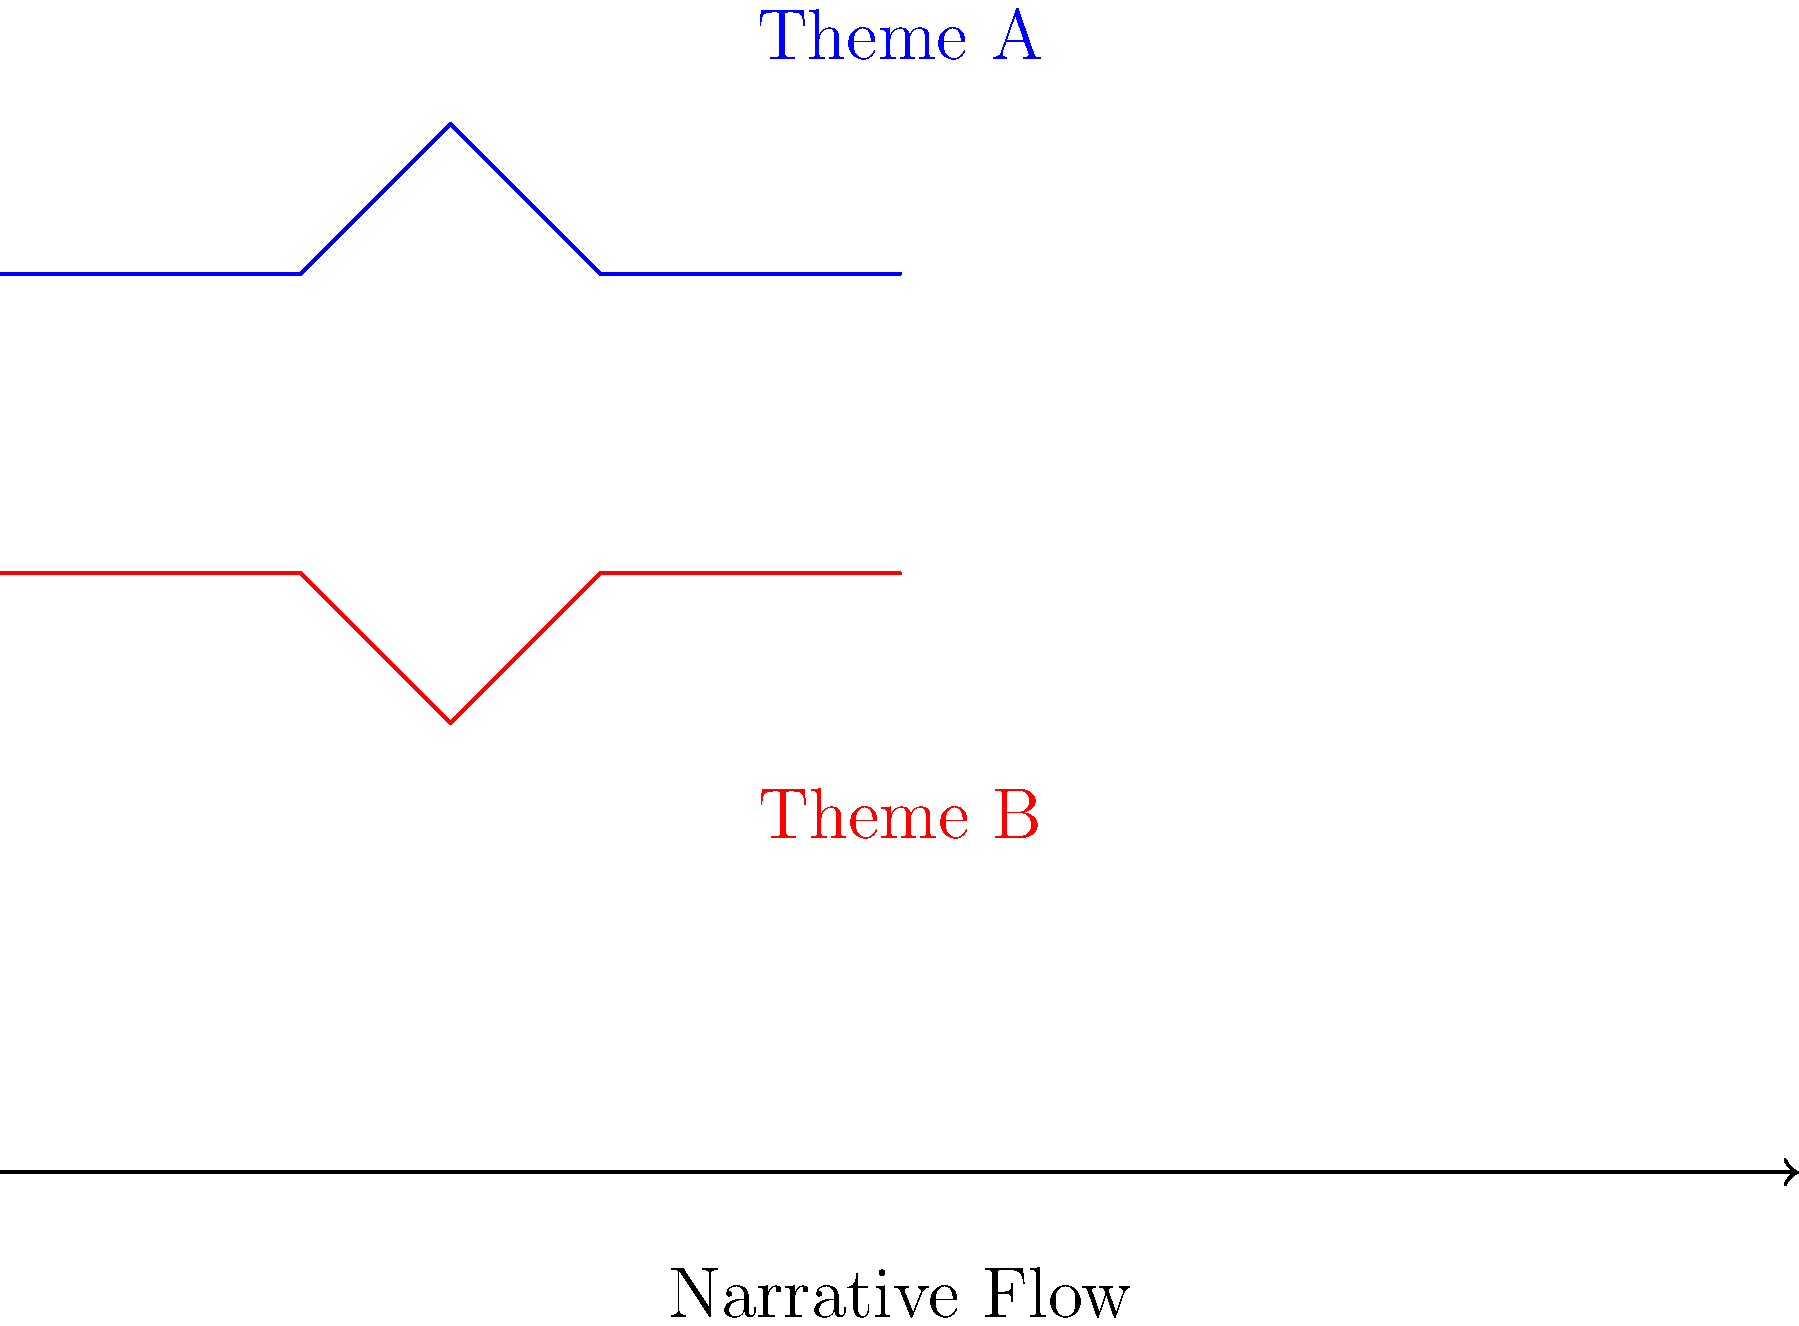In the context of narrative structure, how does the glide reflection illustrated in the frieze pattern above relate to the recurring themes across multiple works? Explain the significance of this transformation in enhancing narrative flow and clarity. 1. Observe the frieze pattern: The blue path (Theme A) is reflected and translated to create the red path (Theme B).

2. Glide reflection: This transformation combines reflection and translation. In literature, it represents how themes are mirrored and shifted across a narrative or multiple works.

3. Recurring themes: The similarity between Theme A and Theme B shows how core ideas persist but are presented from different perspectives or at different points in the story.

4. Narrative flow: The horizontal arrow represents the progression of the narrative. The glide reflection shows how themes evolve along this flow.

5. Clarity enhancement: By presenting themes in a transformed manner, authors can:
   a) Reinforce key ideas without exact repetition
   b) Show theme development or different facets of a concept
   c) Create symmetry and balance in the overall narrative structure

6. Multiple works: This pattern can extend across an author's body of work, showing thematic consistency and evolution over time.

7. Author's technique: Understanding this transformation allows authors to consciously structure their narratives, ensuring themes are presented in varied yet cohesive ways.
Answer: Glide reflection in recurring themes enhances narrative flow by presenting core ideas from different perspectives, creating symmetry and balance while allowing thematic evolution across the story or multiple works. 